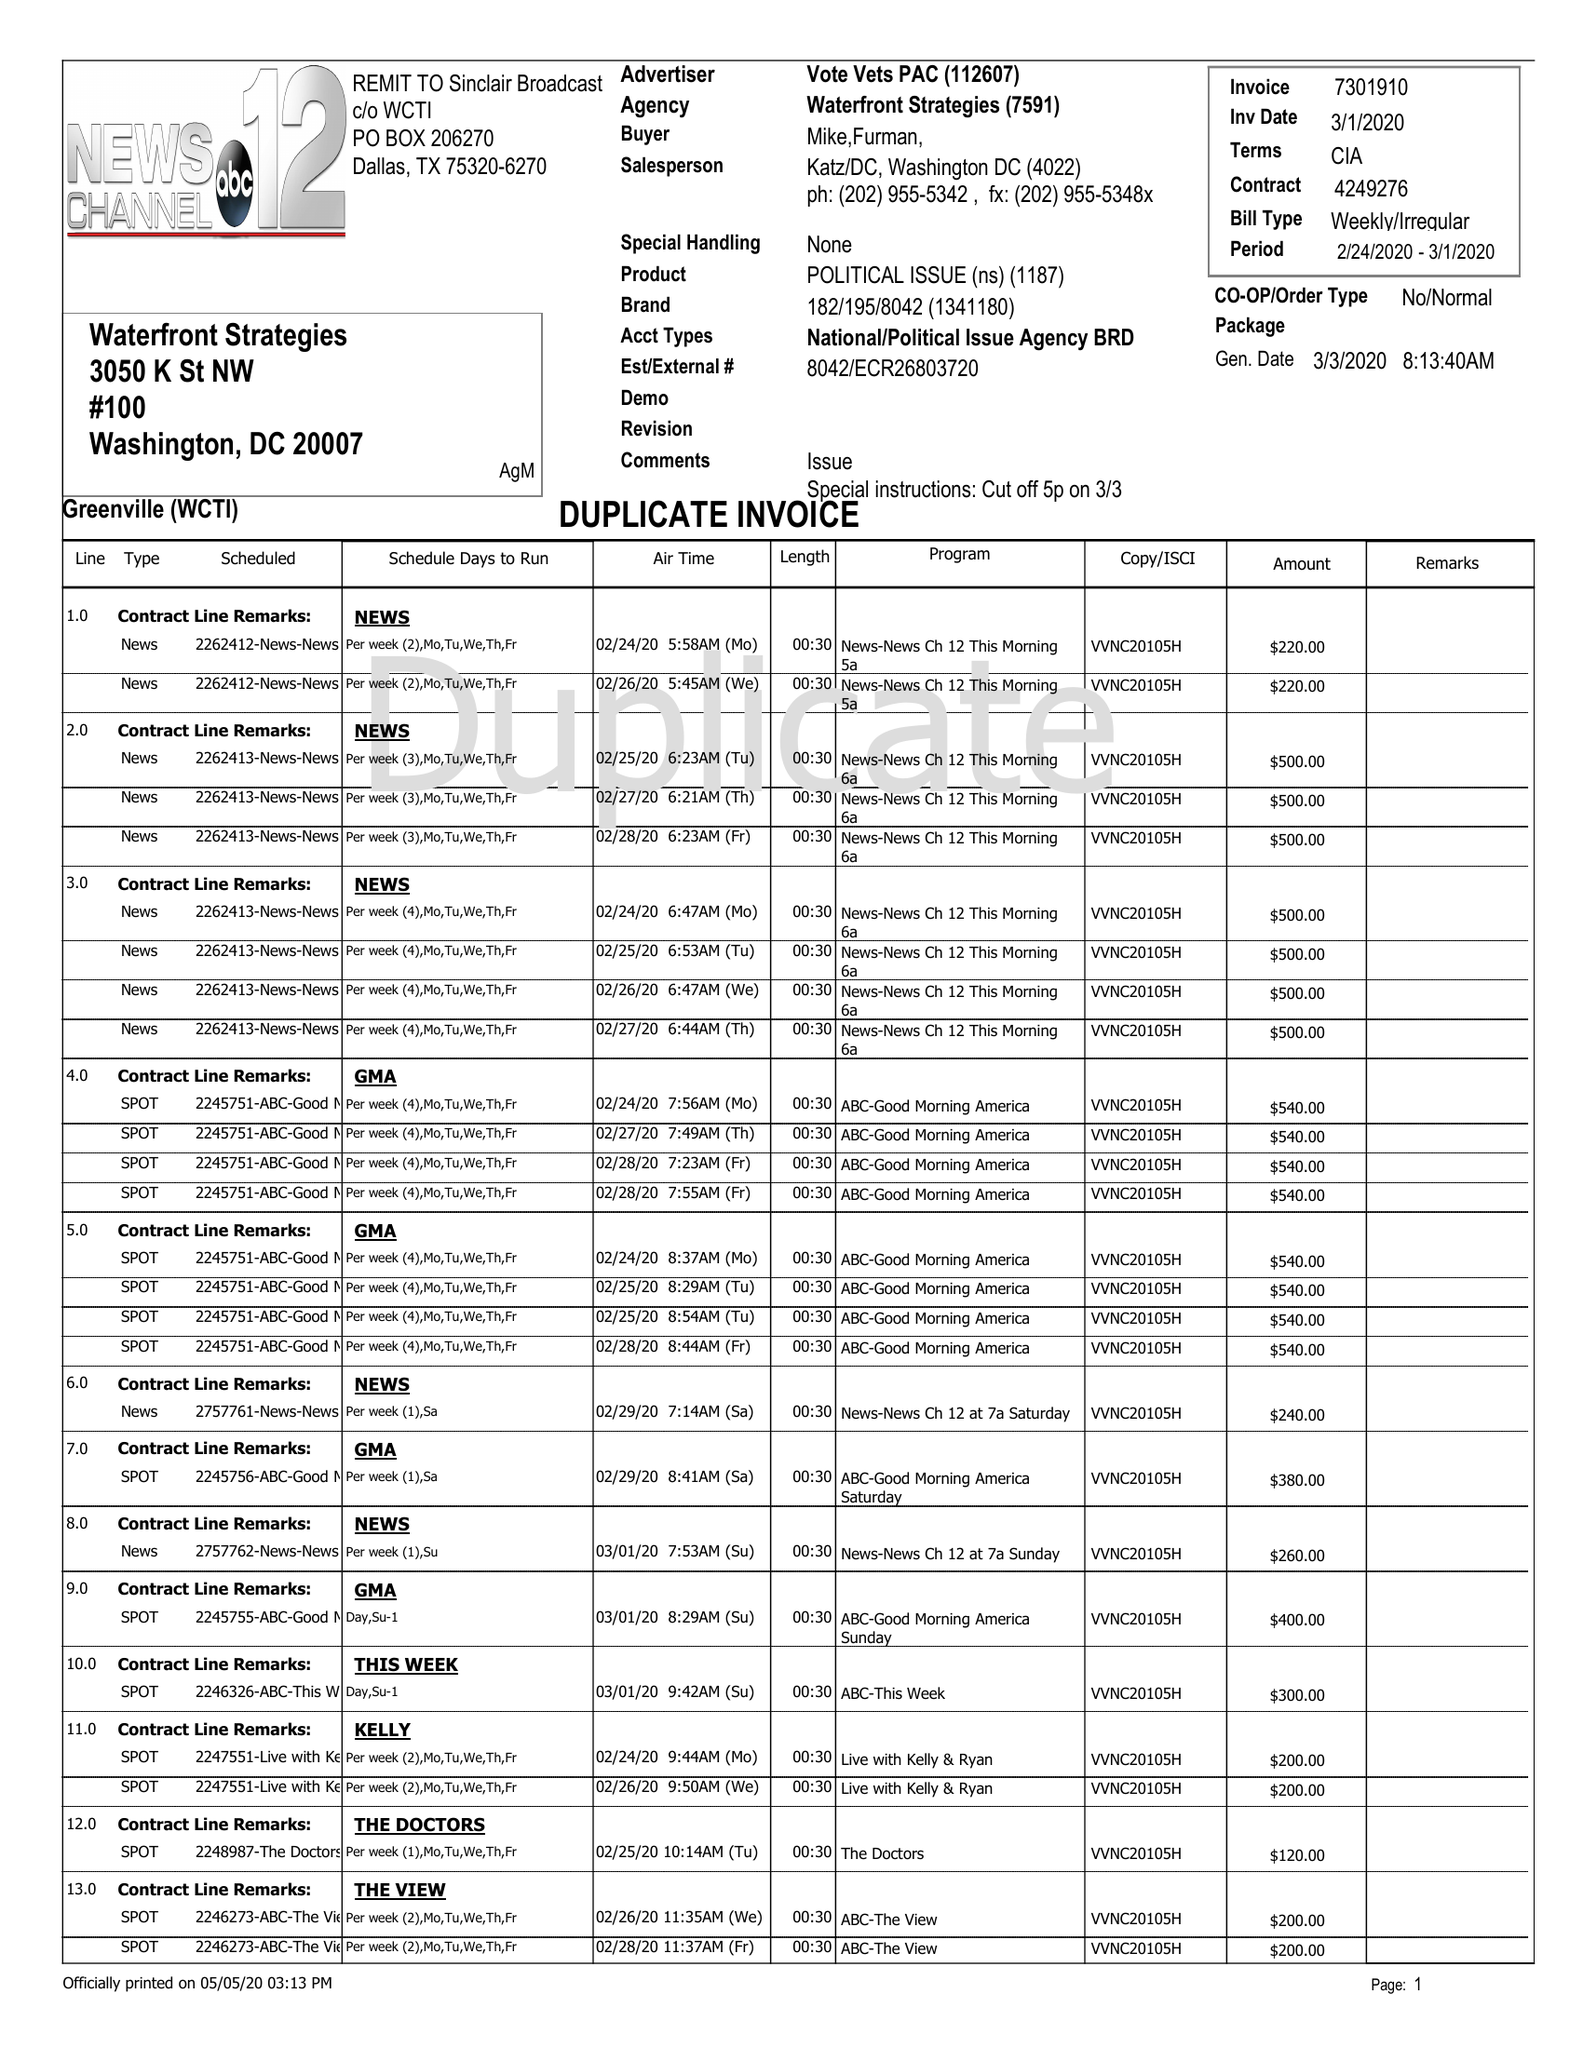What is the value for the flight_to?
Answer the question using a single word or phrase. 03/01/20 